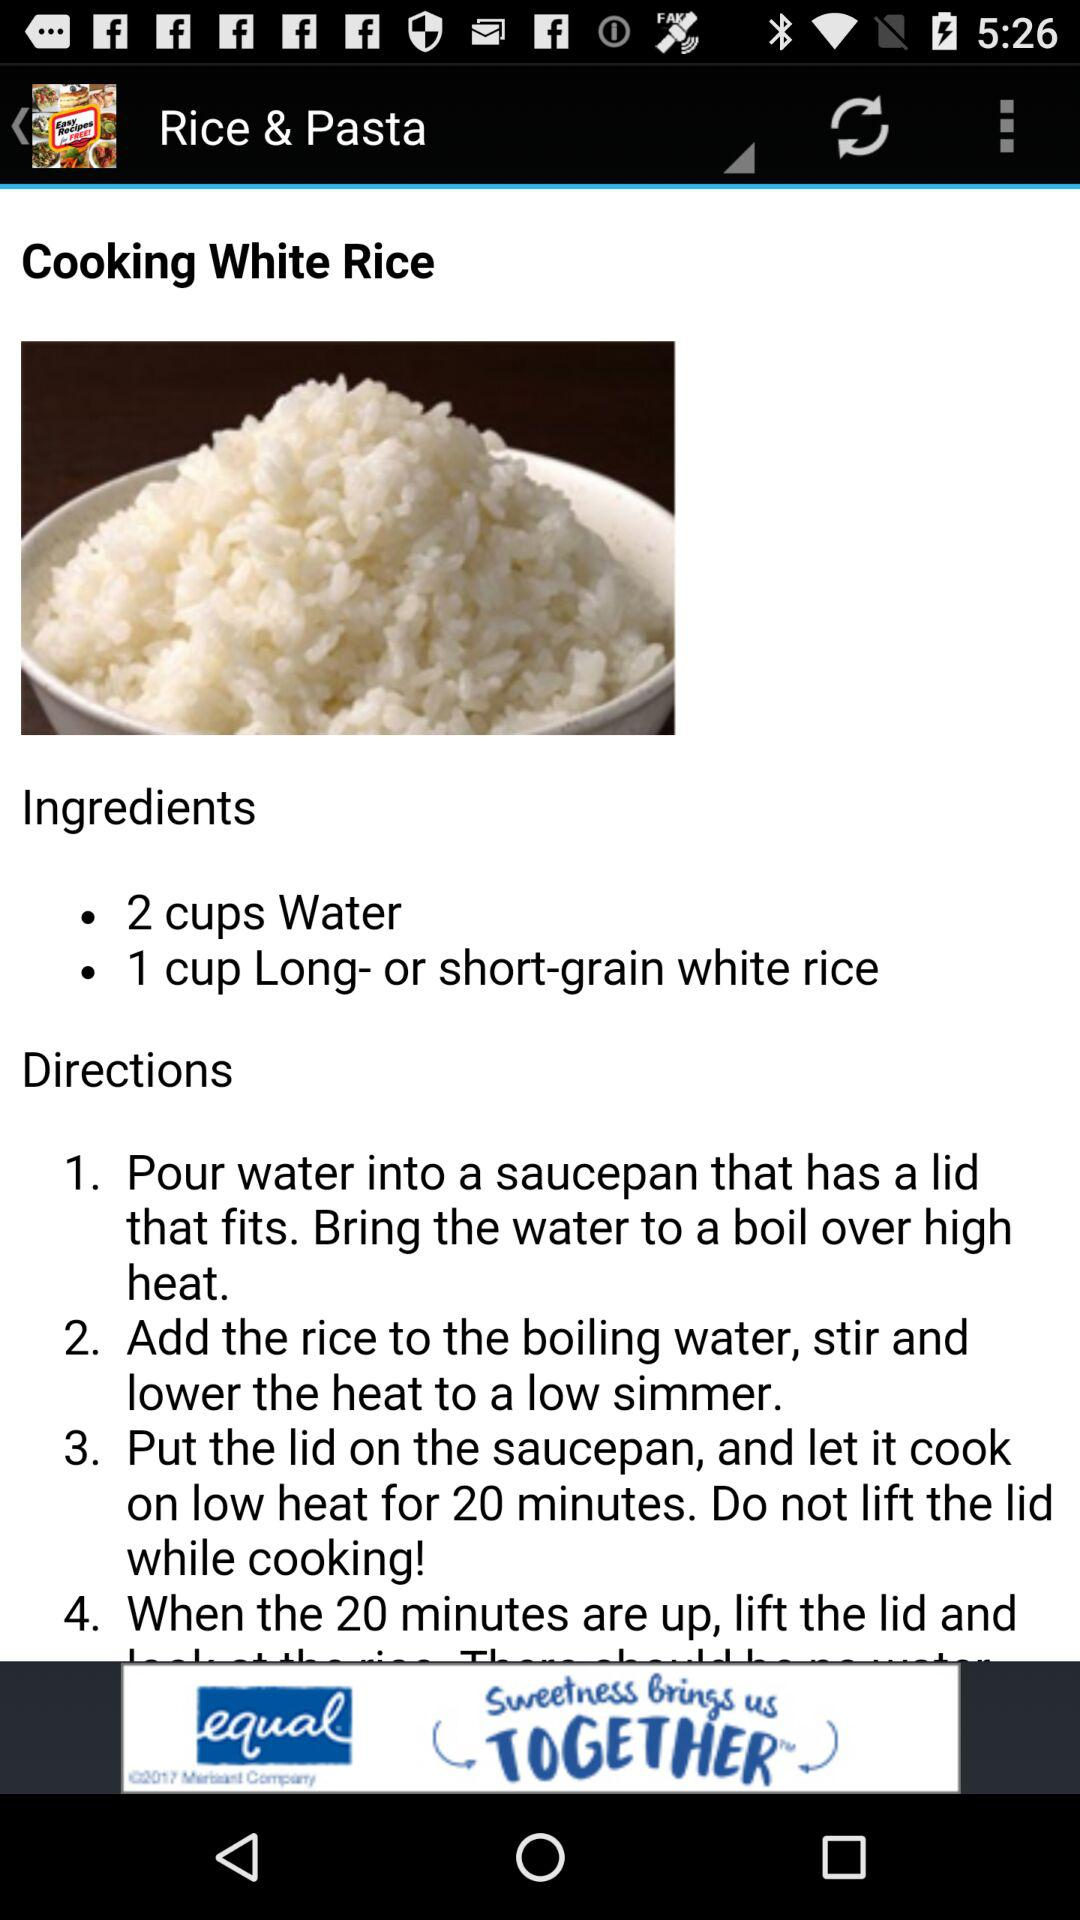How many steps are there in the directions?
Answer the question using a single word or phrase. 4 